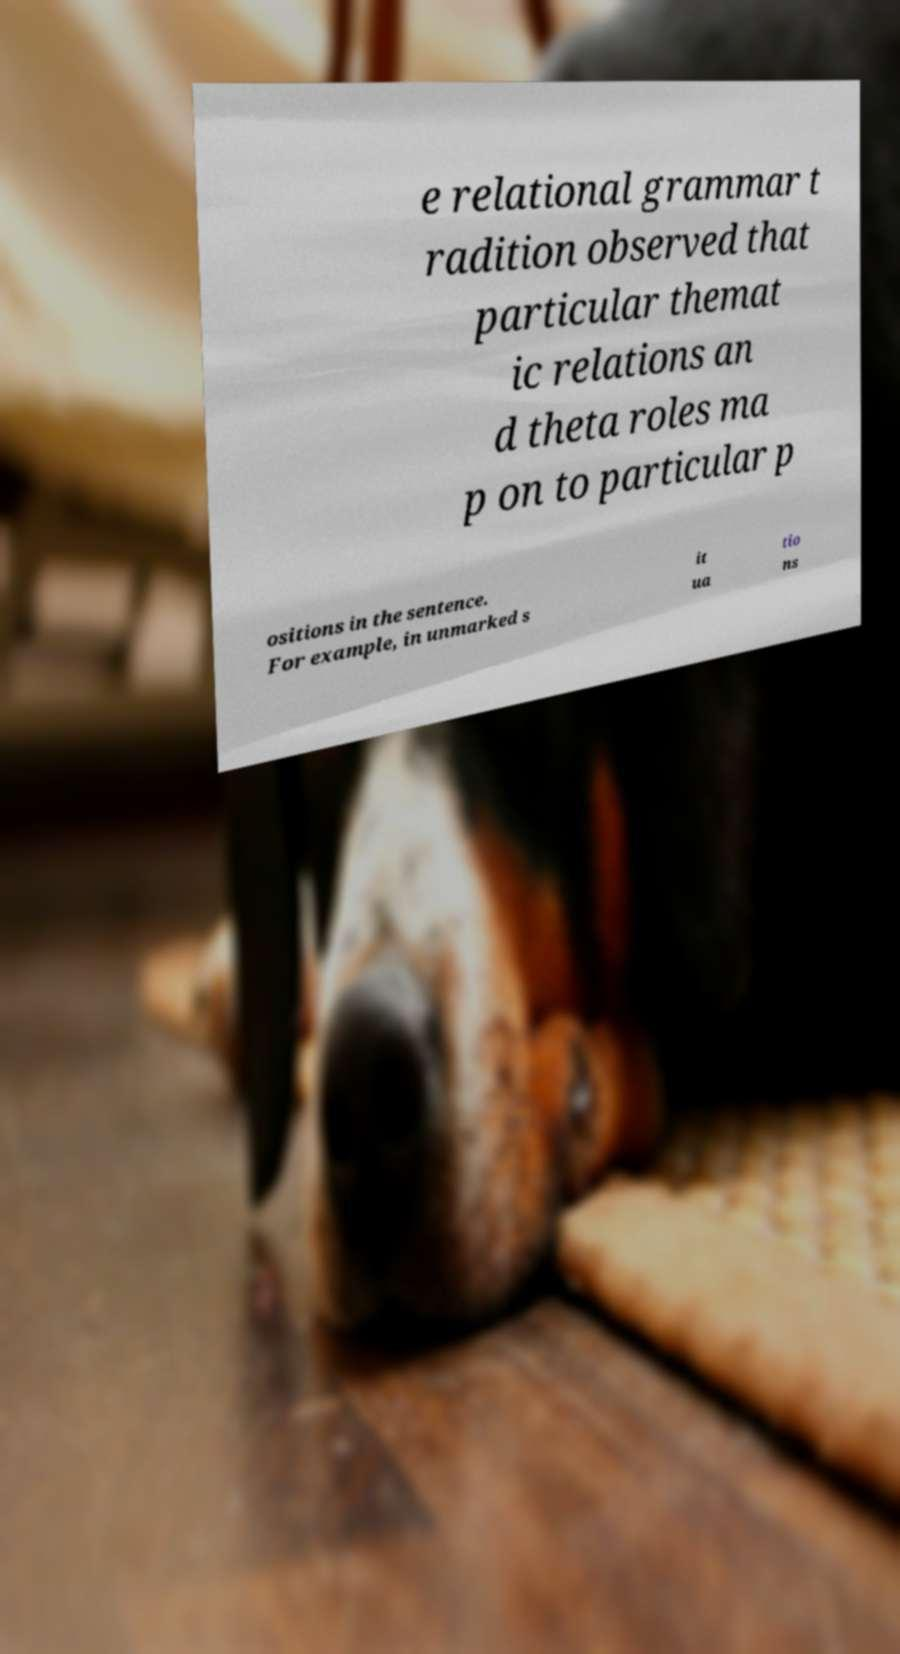For documentation purposes, I need the text within this image transcribed. Could you provide that? e relational grammar t radition observed that particular themat ic relations an d theta roles ma p on to particular p ositions in the sentence. For example, in unmarked s it ua tio ns 